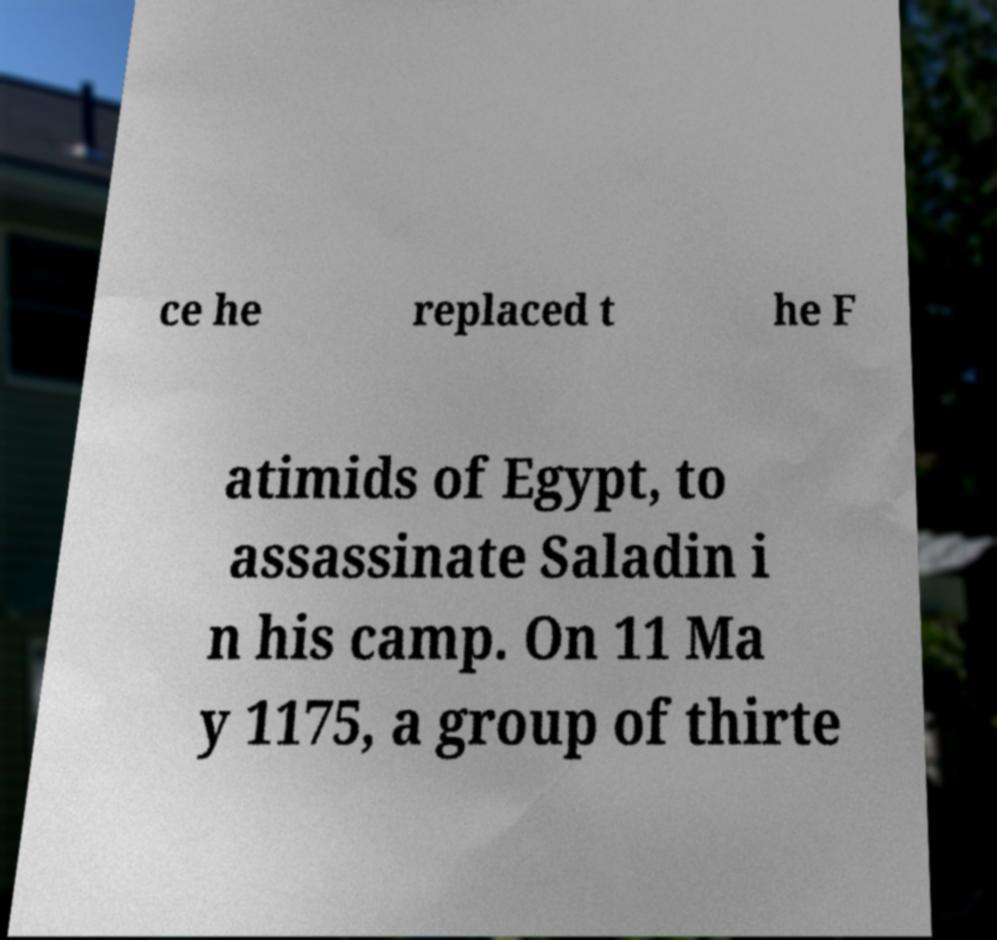Please identify and transcribe the text found in this image. ce he replaced t he F atimids of Egypt, to assassinate Saladin i n his camp. On 11 Ma y 1175, a group of thirte 